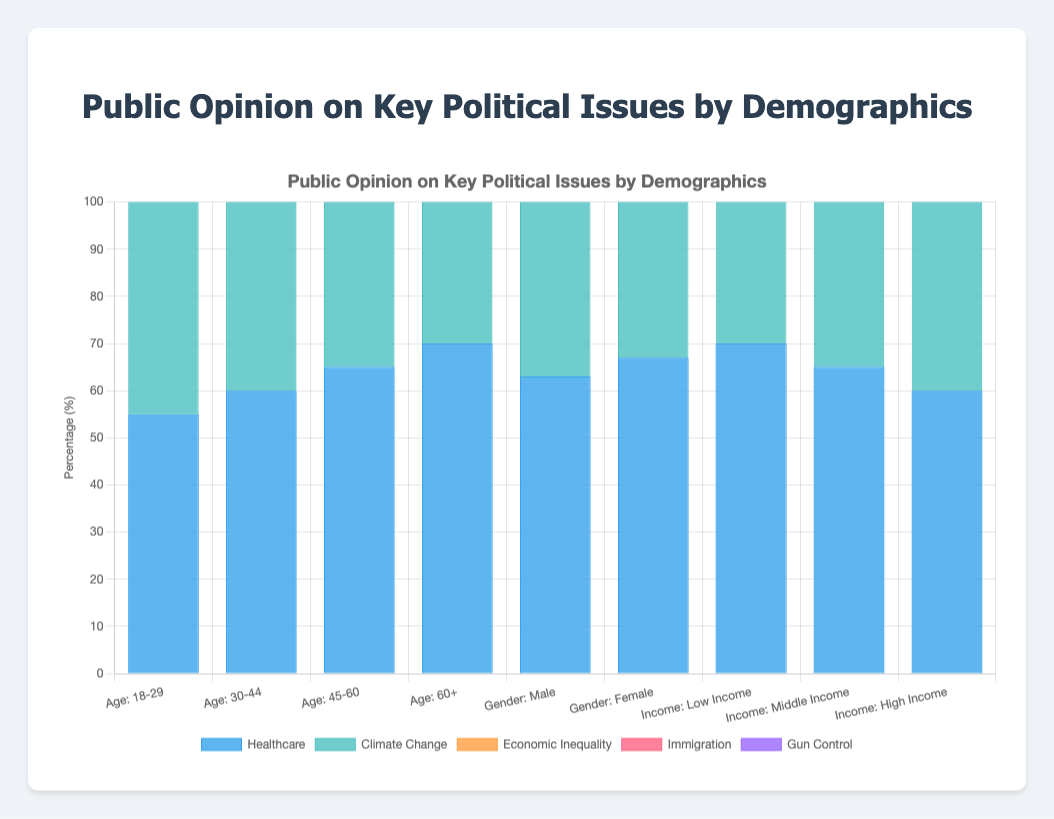Which demographic group shows the highest support for gun control? The "Age: 18-29" group shows the highest support for gun control with a percentage of 70. Compare all the percentages for gun control across demographics to find the highest value.
Answer: Age: 18-29 Which age group has the least concern about economic inequality? The "Age: 60+" group has the least concern about economic inequality with a percentage of 40. Compare economic inequality percentages across all age groups to identify the lowest value.
Answer: Age: 60+ What is the average level of concern about healthcare across all gender groups? For healthcare, the percentages for "Male" and "Female" groups are 63 and 67, respectively. Average them: (63 + 67) / 2 = 130 / 2 = 65.
Answer: 65 Which demographic category shows a higher concern for immigration, income or gender? Compare the average immigration percentages across the "Income" and "Gender" categories. "Gender" has values 53 and 45, averaging to 49. "Income" has values 40, 50, and 55, averaging to 48. "Gender" has a slightly higher average.
Answer: Gender Which demographics have the highest and lowest support for climate change action? Compare the climate change percentages for all demographics. The "Age: 18-29" group has the highest support at 62, and the "Age: 60+" group has the lowest support at 48.
Answer: Highest: Age: 18-29, Lowest: Age: 60+ What is the difference in support for healthcare between the youngest and oldest age groups? Subtract the healthcare percentage of the "Age: 18-29" group (55) from that of the "Age: 60+" group (70). 70 - 55 = 15.
Answer: 15 Which demographic shows more concern for economic inequality, "Low Income" or "30-44" age group? Compare the economic inequality percentages between the "Low Income" (65) and "Age: 30-44" (50). The "Low Income" group shows more concern.
Answer: Low Income What's the combined total support for gun control among all age groups? Add up the gun control percentages across all age groups: 70 + 65 + 60 + 55 = 250.
Answer: 250 How does female support for immigration compare to that of "Middle Income"? Compare the immigration percentages for "Female" (45) and "Middle Income" (50). The "Middle Income" group has higher support.
Answer: Middle Income What is the range of support for climate change action across all income groups? Identify the minimum and maximum Climate Change percentages among income groups: Min (Low Income: 54), Max (Middle Income: 58). The range is 58 - 54 = 4.
Answer: 4 